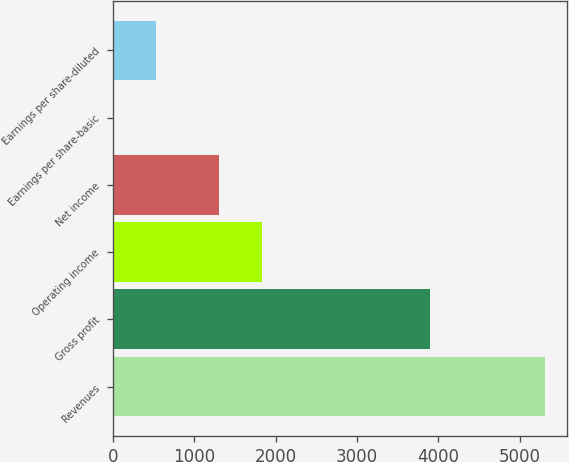Convert chart to OTSL. <chart><loc_0><loc_0><loc_500><loc_500><bar_chart><fcel>Revenues<fcel>Gross profit<fcel>Operating income<fcel>Net income<fcel>Earnings per share-basic<fcel>Earnings per share-diluted<nl><fcel>5313<fcel>3902<fcel>1834.28<fcel>1303<fcel>0.25<fcel>531.52<nl></chart> 